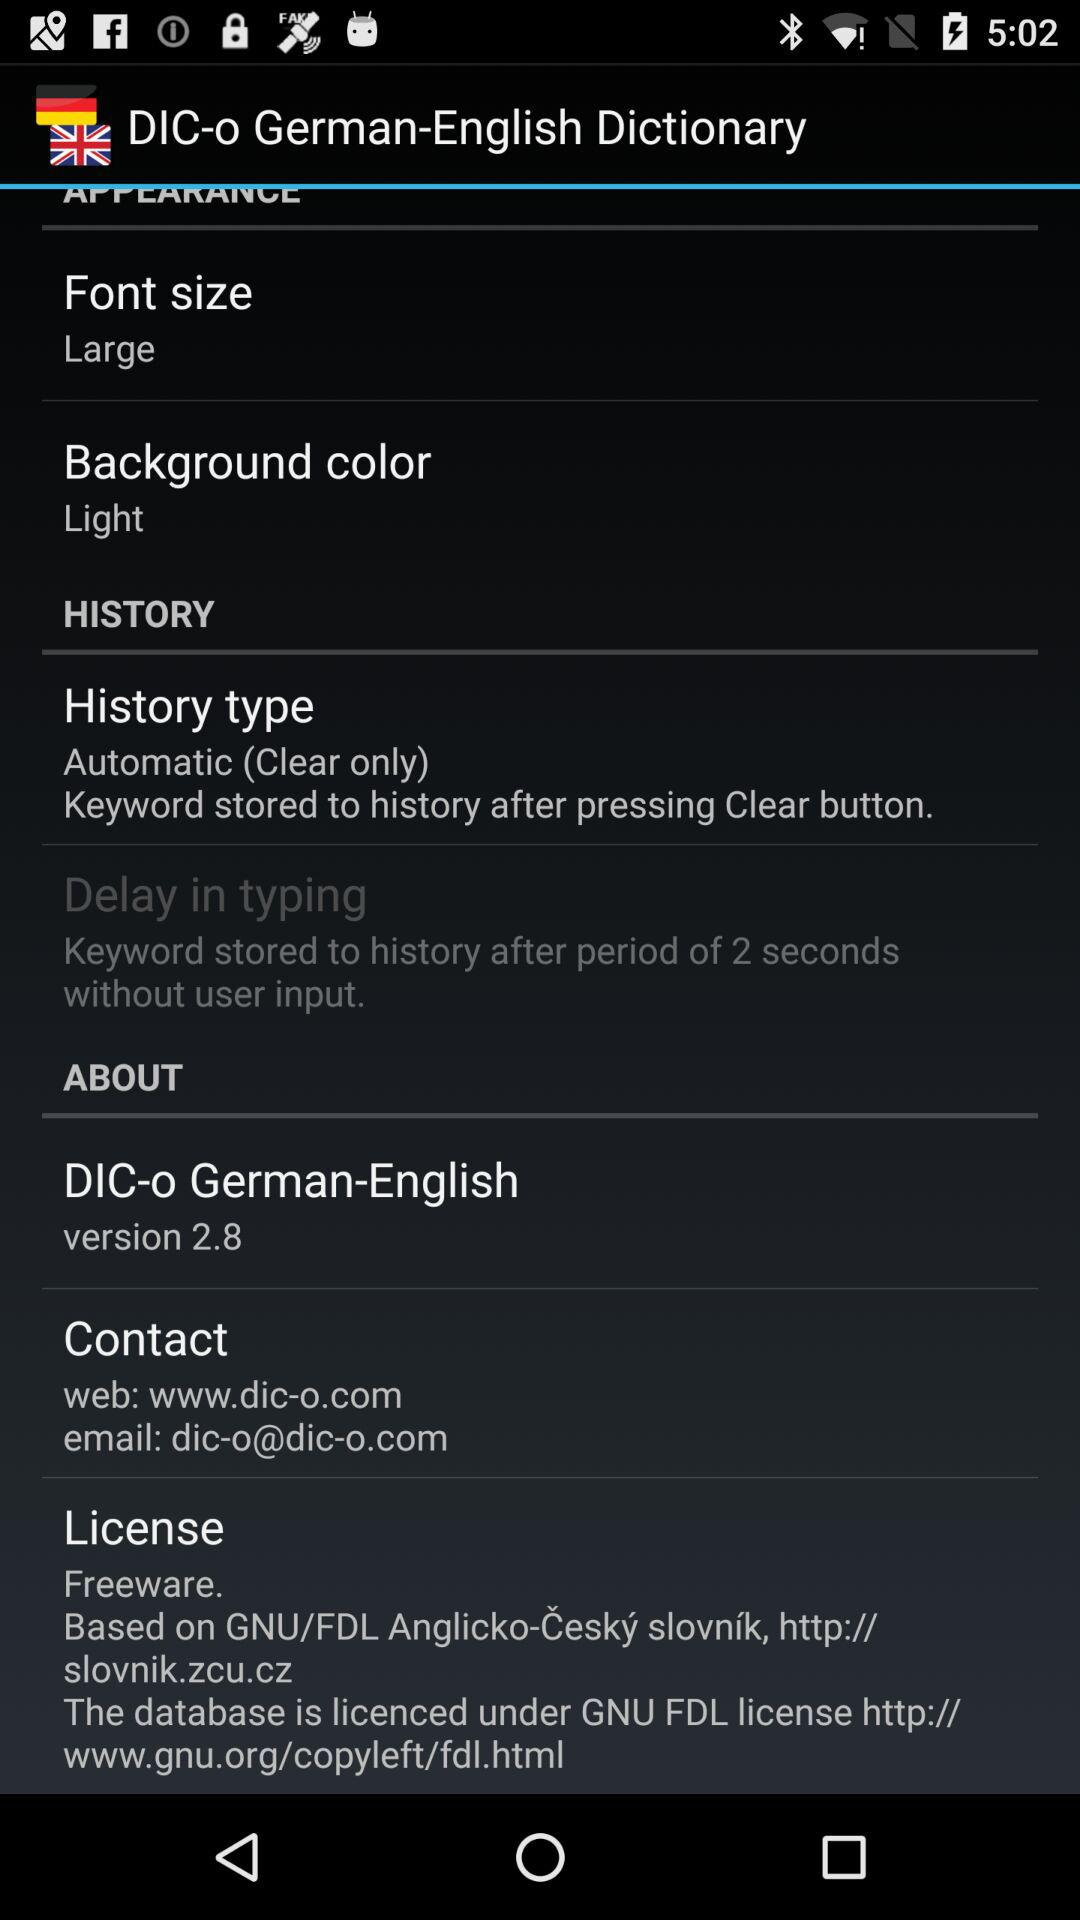What is the background color? The background color is "Light". 